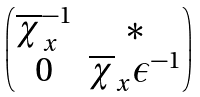<formula> <loc_0><loc_0><loc_500><loc_500>\begin{pmatrix} \overline { \chi } _ { x } ^ { - 1 } & * \\ 0 & \overline { \chi } _ { x } \epsilon ^ { - 1 } \end{pmatrix}</formula> 